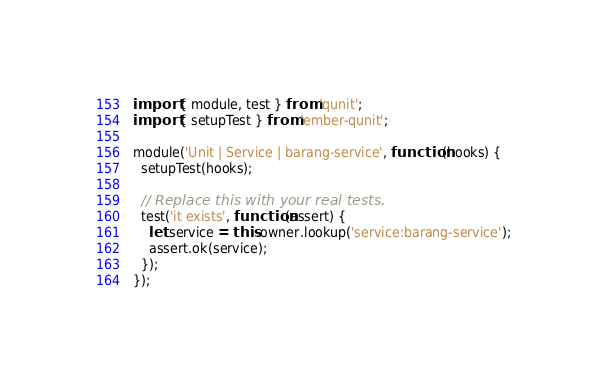<code> <loc_0><loc_0><loc_500><loc_500><_JavaScript_>import { module, test } from 'qunit';
import { setupTest } from 'ember-qunit';

module('Unit | Service | barang-service', function(hooks) {
  setupTest(hooks);

  // Replace this with your real tests.
  test('it exists', function(assert) {
    let service = this.owner.lookup('service:barang-service');
    assert.ok(service);
  });
});

</code> 